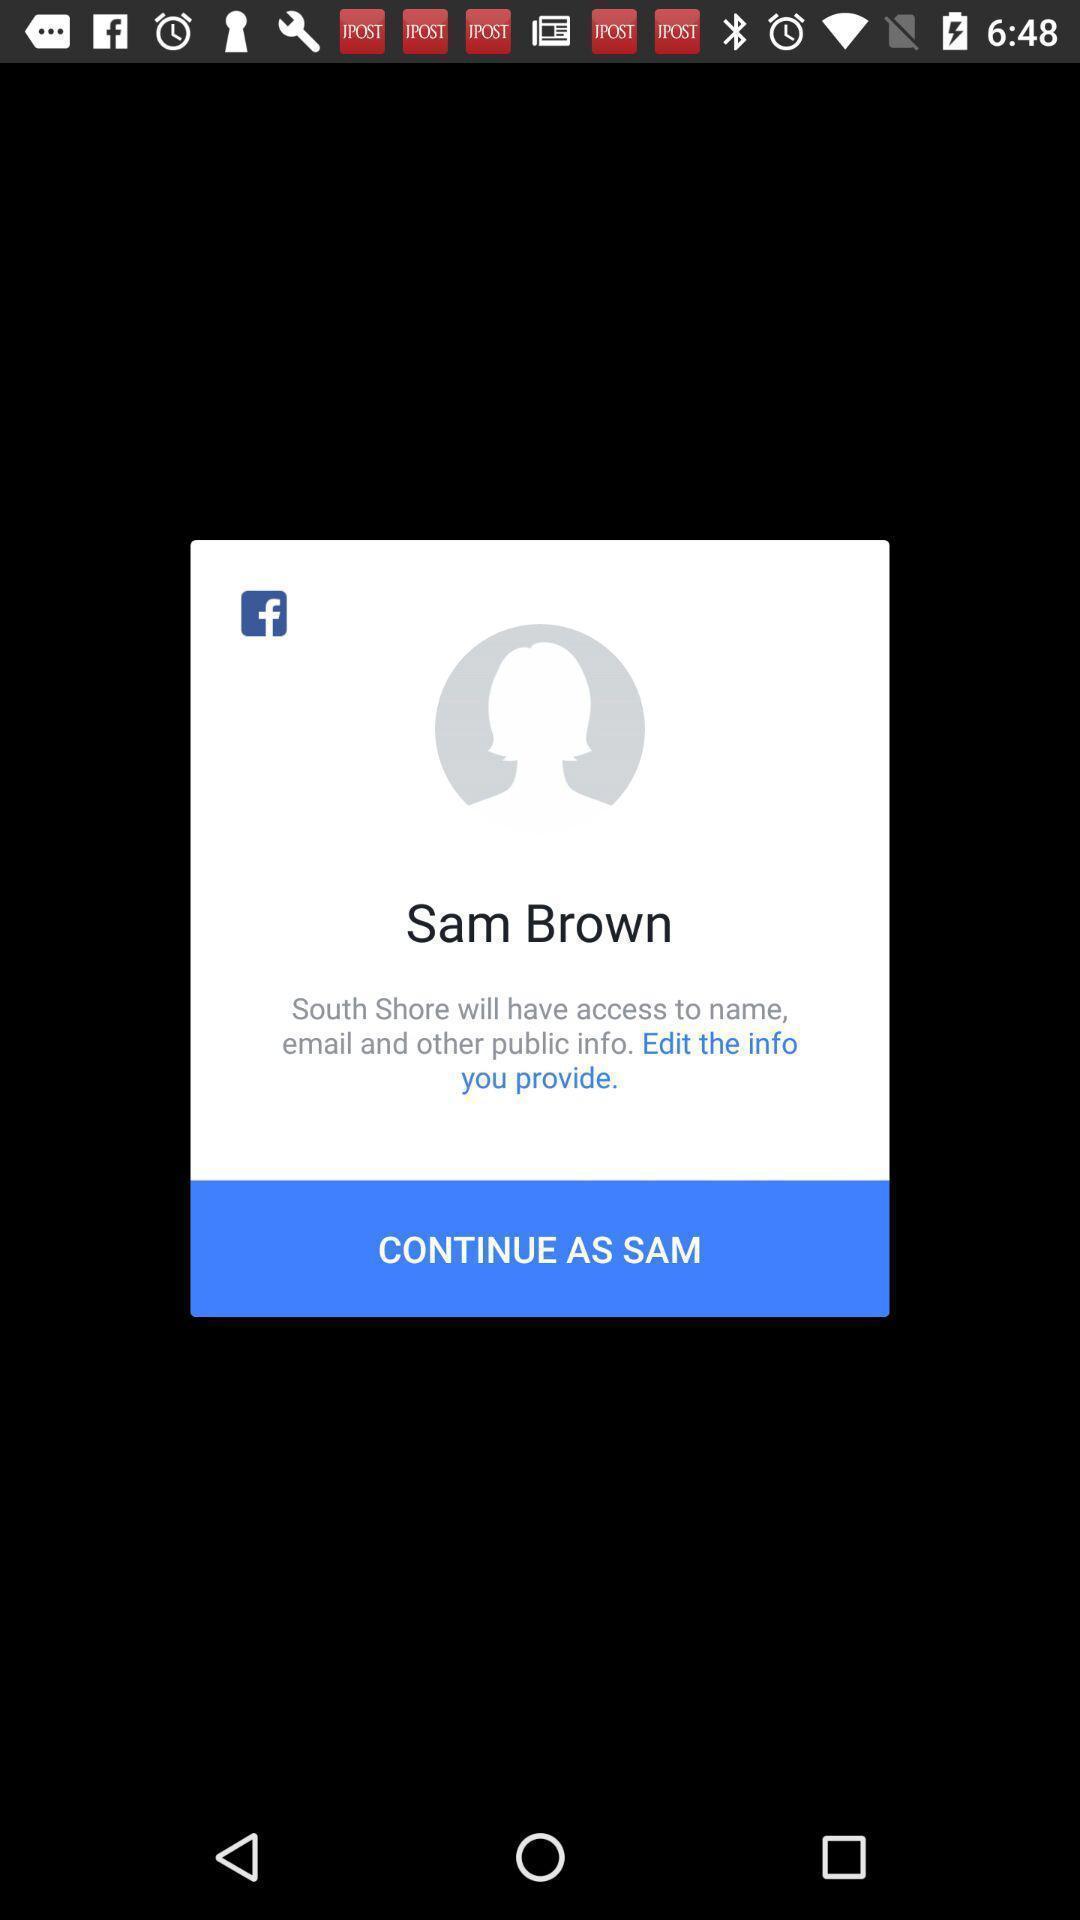Provide a description of this screenshot. Pop-up to continue as sam. 